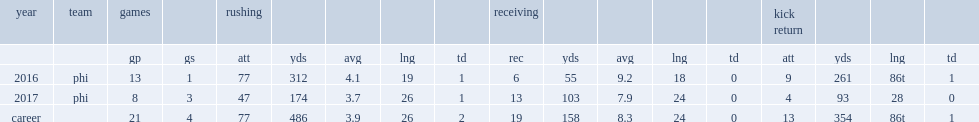How many rushing yards did wendell smallwood get in 2016? 312.0. 